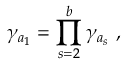Convert formula to latex. <formula><loc_0><loc_0><loc_500><loc_500>\gamma _ { a _ { 1 } } = \prod _ { s = 2 } ^ { b } \gamma _ { a _ { s } } ,</formula> 